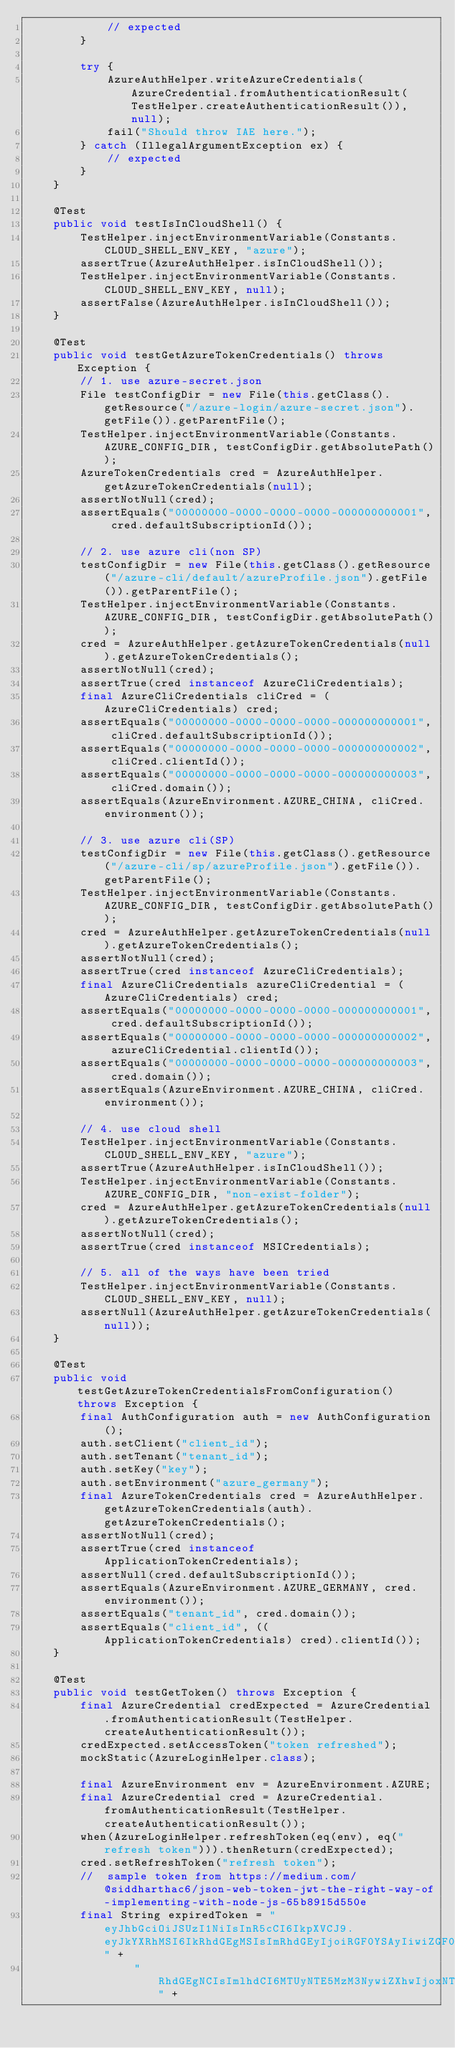Convert code to text. <code><loc_0><loc_0><loc_500><loc_500><_Java_>            // expected
        }

        try {
            AzureAuthHelper.writeAzureCredentials(AzureCredential.fromAuthenticationResult(TestHelper.createAuthenticationResult()), null);
            fail("Should throw IAE here.");
        } catch (IllegalArgumentException ex) {
            // expected
        }
    }

    @Test
    public void testIsInCloudShell() {
        TestHelper.injectEnvironmentVariable(Constants.CLOUD_SHELL_ENV_KEY, "azure");
        assertTrue(AzureAuthHelper.isInCloudShell());
        TestHelper.injectEnvironmentVariable(Constants.CLOUD_SHELL_ENV_KEY, null);
        assertFalse(AzureAuthHelper.isInCloudShell());
    }

    @Test
    public void testGetAzureTokenCredentials() throws Exception {
        // 1. use azure-secret.json
        File testConfigDir = new File(this.getClass().getResource("/azure-login/azure-secret.json").getFile()).getParentFile();
        TestHelper.injectEnvironmentVariable(Constants.AZURE_CONFIG_DIR, testConfigDir.getAbsolutePath());
        AzureTokenCredentials cred = AzureAuthHelper.getAzureTokenCredentials(null);
        assertNotNull(cred);
        assertEquals("00000000-0000-0000-0000-000000000001", cred.defaultSubscriptionId());

        // 2. use azure cli(non SP)
        testConfigDir = new File(this.getClass().getResource("/azure-cli/default/azureProfile.json").getFile()).getParentFile();
        TestHelper.injectEnvironmentVariable(Constants.AZURE_CONFIG_DIR, testConfigDir.getAbsolutePath());
        cred = AzureAuthHelper.getAzureTokenCredentials(null).getAzureTokenCredentials();
        assertNotNull(cred);
        assertTrue(cred instanceof AzureCliCredentials);
        final AzureCliCredentials cliCred = (AzureCliCredentials) cred;
        assertEquals("00000000-0000-0000-0000-000000000001", cliCred.defaultSubscriptionId());
        assertEquals("00000000-0000-0000-0000-000000000002", cliCred.clientId());
        assertEquals("00000000-0000-0000-0000-000000000003", cliCred.domain());
        assertEquals(AzureEnvironment.AZURE_CHINA, cliCred.environment());

        // 3. use azure cli(SP)
        testConfigDir = new File(this.getClass().getResource("/azure-cli/sp/azureProfile.json").getFile()).getParentFile();
        TestHelper.injectEnvironmentVariable(Constants.AZURE_CONFIG_DIR, testConfigDir.getAbsolutePath());
        cred = AzureAuthHelper.getAzureTokenCredentials(null).getAzureTokenCredentials();
        assertNotNull(cred);
        assertTrue(cred instanceof AzureCliCredentials);
        final AzureCliCredentials azureCliCredential = (AzureCliCredentials) cred;
        assertEquals("00000000-0000-0000-0000-000000000001", cred.defaultSubscriptionId());
        assertEquals("00000000-0000-0000-0000-000000000002", azureCliCredential.clientId());
        assertEquals("00000000-0000-0000-0000-000000000003", cred.domain());
        assertEquals(AzureEnvironment.AZURE_CHINA, cliCred.environment());

        // 4. use cloud shell
        TestHelper.injectEnvironmentVariable(Constants.CLOUD_SHELL_ENV_KEY, "azure");
        assertTrue(AzureAuthHelper.isInCloudShell());
        TestHelper.injectEnvironmentVariable(Constants.AZURE_CONFIG_DIR, "non-exist-folder");
        cred = AzureAuthHelper.getAzureTokenCredentials(null).getAzureTokenCredentials();
        assertNotNull(cred);
        assertTrue(cred instanceof MSICredentials);

        // 5. all of the ways have been tried
        TestHelper.injectEnvironmentVariable(Constants.CLOUD_SHELL_ENV_KEY, null);
        assertNull(AzureAuthHelper.getAzureTokenCredentials(null));
    }

    @Test
    public void testGetAzureTokenCredentialsFromConfiguration() throws Exception {
        final AuthConfiguration auth = new AuthConfiguration();
        auth.setClient("client_id");
        auth.setTenant("tenant_id");
        auth.setKey("key");
        auth.setEnvironment("azure_germany");
        final AzureTokenCredentials cred = AzureAuthHelper.getAzureTokenCredentials(auth).getAzureTokenCredentials();
        assertNotNull(cred);
        assertTrue(cred instanceof ApplicationTokenCredentials);
        assertNull(cred.defaultSubscriptionId());
        assertEquals(AzureEnvironment.AZURE_GERMANY, cred.environment());
        assertEquals("tenant_id", cred.domain());
        assertEquals("client_id", ((ApplicationTokenCredentials) cred).clientId());
    }

    @Test
    public void testGetToken() throws Exception {
        final AzureCredential credExpected = AzureCredential.fromAuthenticationResult(TestHelper.createAuthenticationResult());
        credExpected.setAccessToken("token refreshed");
        mockStatic(AzureLoginHelper.class);

        final AzureEnvironment env = AzureEnvironment.AZURE;
        final AzureCredential cred = AzureCredential.fromAuthenticationResult(TestHelper.createAuthenticationResult());
        when(AzureLoginHelper.refreshToken(eq(env), eq("refresh token"))).thenReturn(credExpected);
        cred.setRefreshToken("refresh token");
        //  sample token from https://medium.com/@siddharthac6/json-web-token-jwt-the-right-way-of-implementing-with-node-js-65b8915d550e
        final String expiredToken = "eyJhbGciOiJSUzI1NiIsInR5cCI6IkpXVCJ9.eyJkYXRhMSI6IkRhdGEgMSIsImRhdGEyIjoiRGF0YSAyIiwiZGF0YTMiOiJEYXRhIDMiLCJkYXRhNCI6Ik" +
                "RhdGEgNCIsImlhdCI6MTUyNTE5MzM3NywiZXhwIjoxNTI1MjM2NTc3LCJhdWQiOiJodHRwOi8vbXlzb2Z0Y29ycC5pbiIsImlzcyI6Ik15c29mdCBjb3JwIiwic3ViIjoic29tZUB1c2" +</code> 